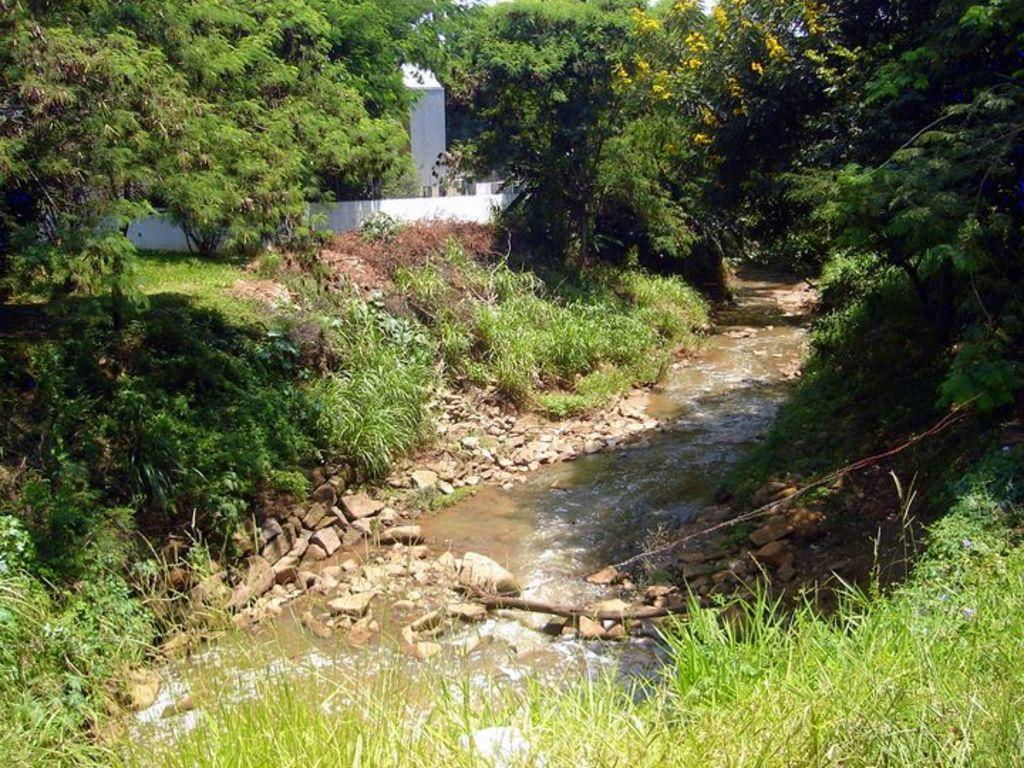What is the primary element visible in the image? There is water in the image. What other objects or features can be seen in the image? There are stones, grass on both the left and right sides, trees in the background, and a house in the background. Can you see any trains passing by in the image? No, there are no trains visible in the image. Is there a squirrel climbing one of the trees in the background? There is no squirrel present in the image. 